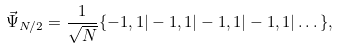<formula> <loc_0><loc_0><loc_500><loc_500>\vec { \Psi } _ { N / 2 } = \frac { 1 } { \sqrt { N } } \{ - 1 , 1 | - 1 , 1 | - 1 , 1 | - 1 , 1 | \dots \} ,</formula> 